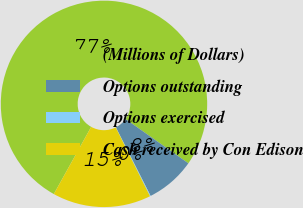Convert chart to OTSL. <chart><loc_0><loc_0><loc_500><loc_500><pie_chart><fcel>(Millions of Dollars)<fcel>Options outstanding<fcel>Options exercised<fcel>Cash received by Con Edison<nl><fcel>76.69%<fcel>7.77%<fcel>0.11%<fcel>15.43%<nl></chart> 